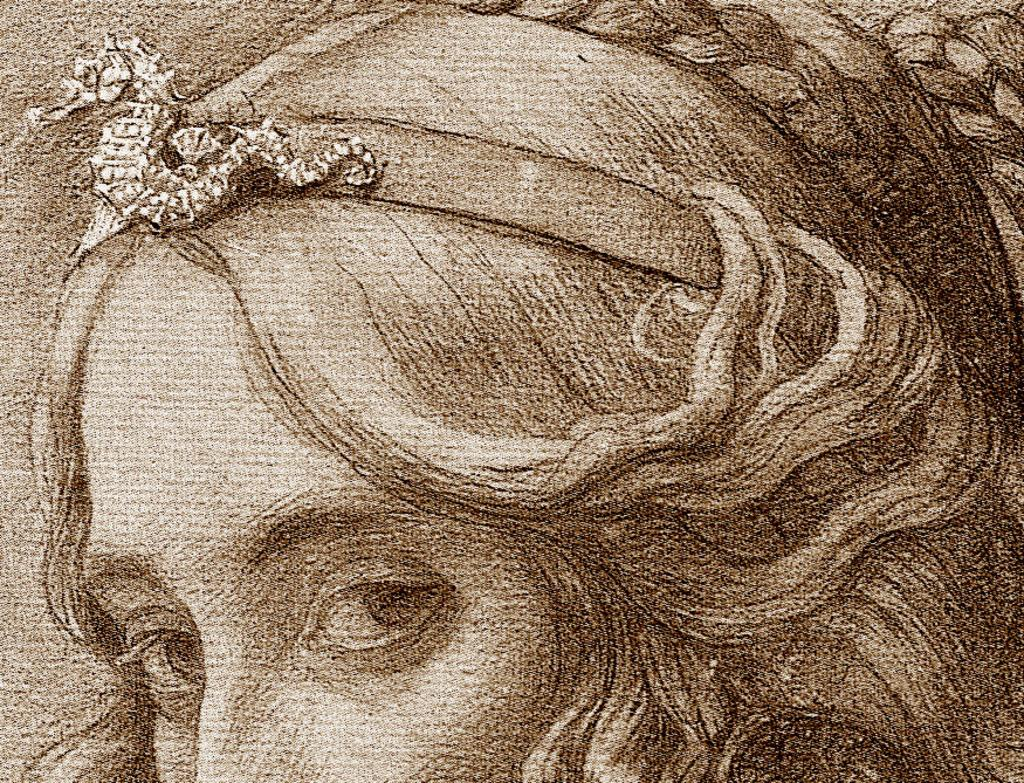What is the main subject of the image? There is a painting in the image. What is depicted in the painting? The painting depicts a woman. Can you tell me how fast the snail is moving in the image? There is no snail present in the image, so it is not possible to determine its speed. 